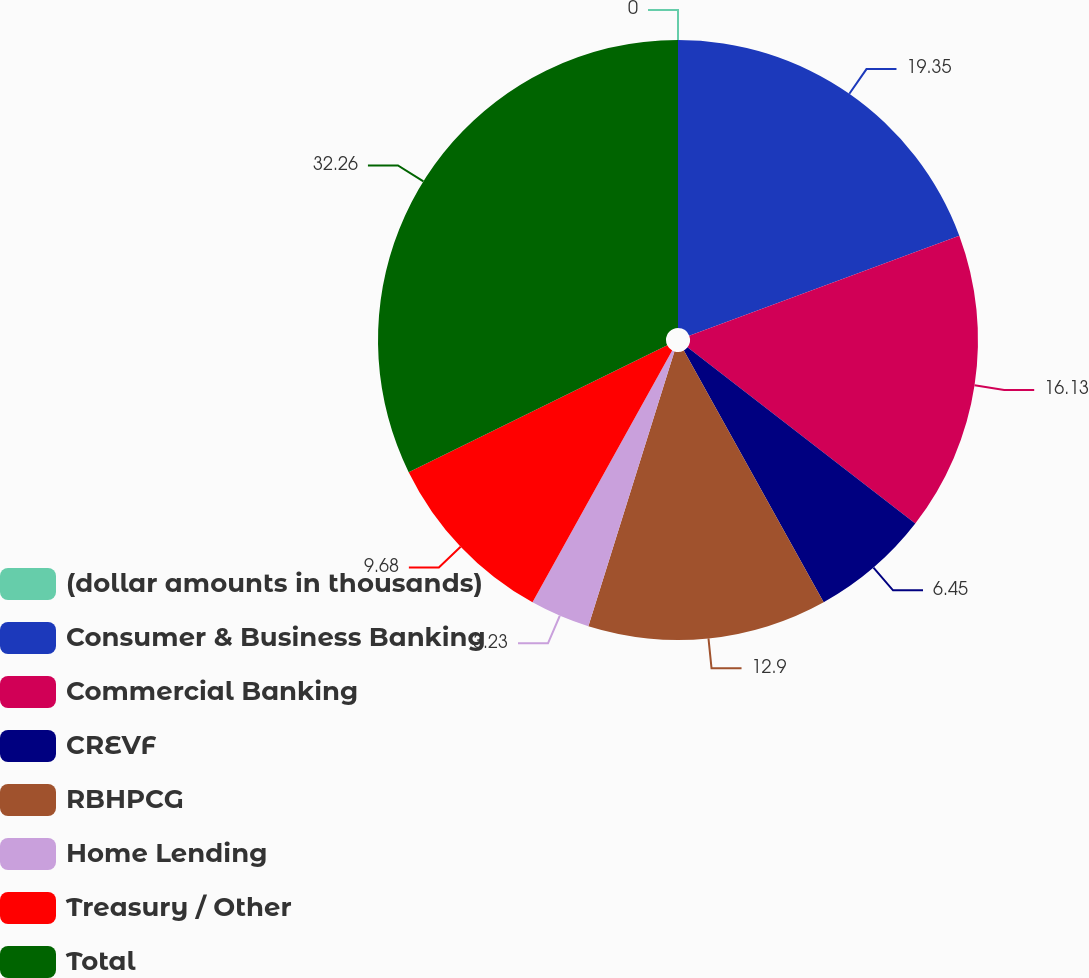Convert chart to OTSL. <chart><loc_0><loc_0><loc_500><loc_500><pie_chart><fcel>(dollar amounts in thousands)<fcel>Consumer & Business Banking<fcel>Commercial Banking<fcel>CREVF<fcel>RBHPCG<fcel>Home Lending<fcel>Treasury / Other<fcel>Total<nl><fcel>0.0%<fcel>19.35%<fcel>16.13%<fcel>6.45%<fcel>12.9%<fcel>3.23%<fcel>9.68%<fcel>32.26%<nl></chart> 